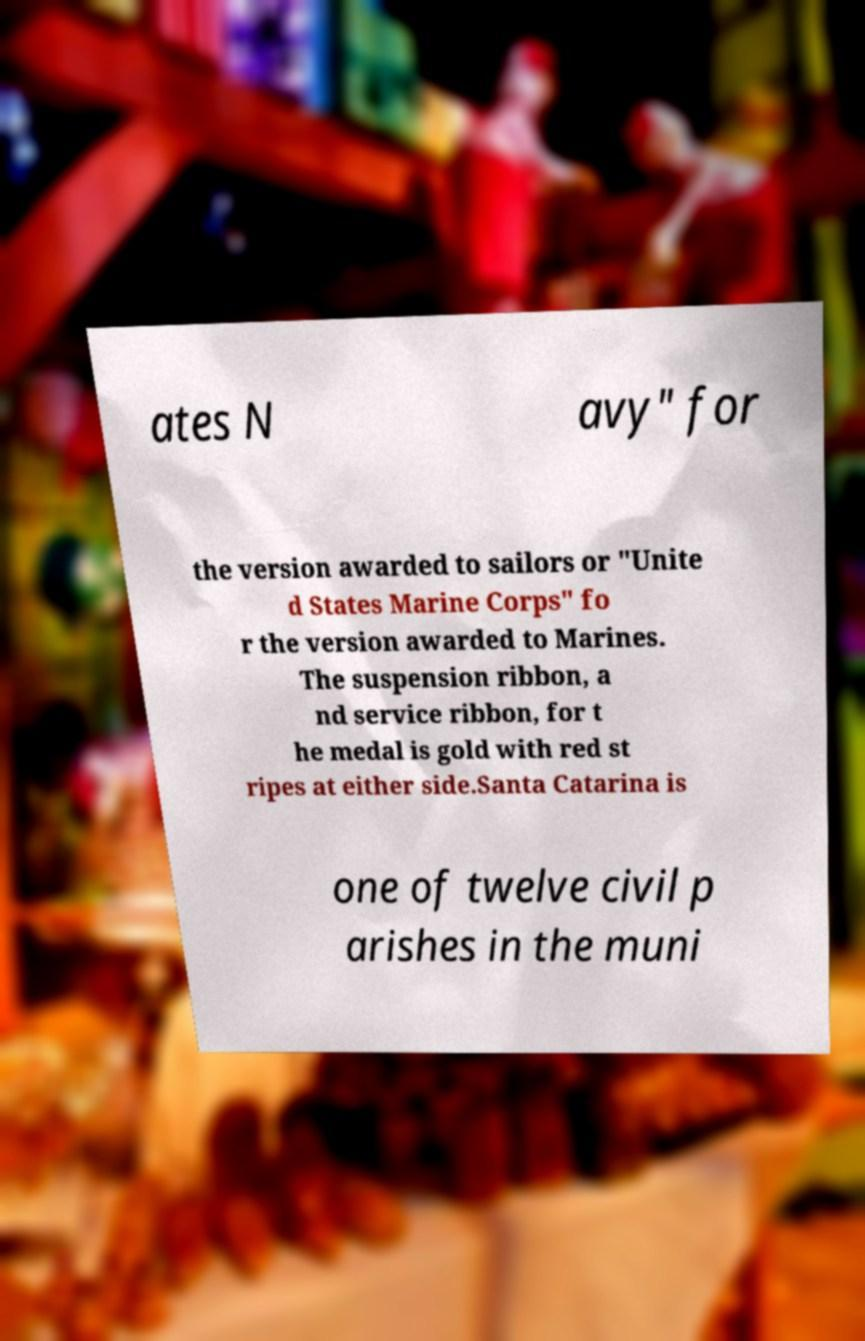What messages or text are displayed in this image? I need them in a readable, typed format. ates N avy" for the version awarded to sailors or "Unite d States Marine Corps" fo r the version awarded to Marines. The suspension ribbon, a nd service ribbon, for t he medal is gold with red st ripes at either side.Santa Catarina is one of twelve civil p arishes in the muni 